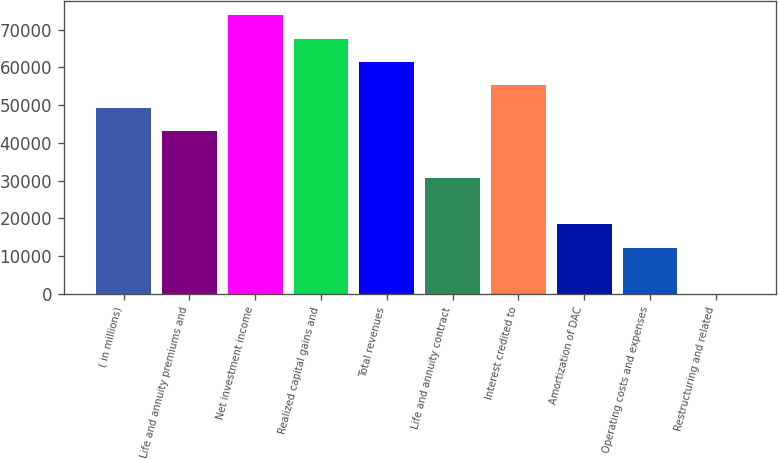<chart> <loc_0><loc_0><loc_500><loc_500><bar_chart><fcel>( in millions)<fcel>Life and annuity premiums and<fcel>Net investment income<fcel>Realized capital gains and<fcel>Total revenues<fcel>Life and annuity contract<fcel>Interest credited to<fcel>Amortization of DAC<fcel>Operating costs and expenses<fcel>Restructuring and related<nl><fcel>49199.4<fcel>43049.6<fcel>73798.6<fcel>67648.8<fcel>61499<fcel>30750<fcel>55349.2<fcel>18450.4<fcel>12300.6<fcel>1<nl></chart> 